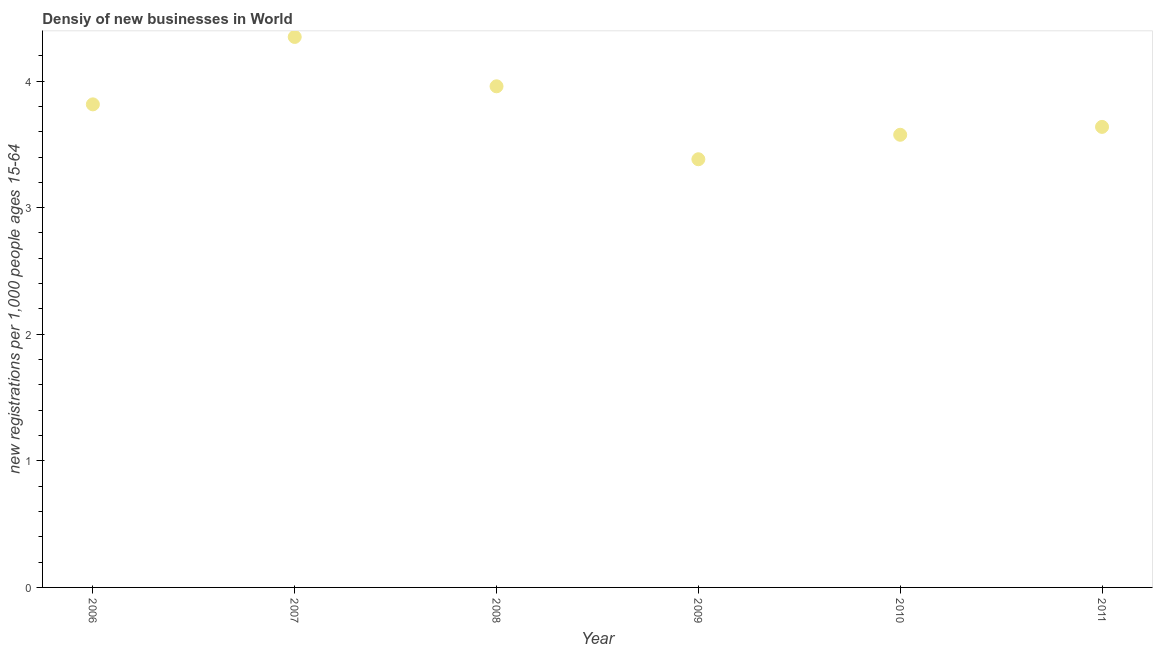What is the density of new business in 2008?
Provide a succinct answer. 3.96. Across all years, what is the maximum density of new business?
Offer a very short reply. 4.35. Across all years, what is the minimum density of new business?
Your answer should be very brief. 3.38. In which year was the density of new business minimum?
Provide a short and direct response. 2009. What is the sum of the density of new business?
Your answer should be compact. 22.72. What is the difference between the density of new business in 2007 and 2008?
Provide a succinct answer. 0.39. What is the average density of new business per year?
Offer a very short reply. 3.79. What is the median density of new business?
Offer a very short reply. 3.73. In how many years, is the density of new business greater than 4 ?
Your answer should be very brief. 1. What is the ratio of the density of new business in 2006 to that in 2010?
Offer a terse response. 1.07. Is the density of new business in 2006 less than that in 2010?
Ensure brevity in your answer.  No. What is the difference between the highest and the second highest density of new business?
Keep it short and to the point. 0.39. Is the sum of the density of new business in 2008 and 2010 greater than the maximum density of new business across all years?
Your answer should be very brief. Yes. What is the difference between the highest and the lowest density of new business?
Your answer should be very brief. 0.97. Does the density of new business monotonically increase over the years?
Your response must be concise. No. How many years are there in the graph?
Give a very brief answer. 6. What is the difference between two consecutive major ticks on the Y-axis?
Give a very brief answer. 1. Does the graph contain grids?
Make the answer very short. No. What is the title of the graph?
Ensure brevity in your answer.  Densiy of new businesses in World. What is the label or title of the Y-axis?
Your answer should be very brief. New registrations per 1,0 people ages 15-64. What is the new registrations per 1,000 people ages 15-64 in 2006?
Your response must be concise. 3.82. What is the new registrations per 1,000 people ages 15-64 in 2007?
Your answer should be very brief. 4.35. What is the new registrations per 1,000 people ages 15-64 in 2008?
Provide a succinct answer. 3.96. What is the new registrations per 1,000 people ages 15-64 in 2009?
Your response must be concise. 3.38. What is the new registrations per 1,000 people ages 15-64 in 2010?
Your answer should be very brief. 3.58. What is the new registrations per 1,000 people ages 15-64 in 2011?
Offer a terse response. 3.64. What is the difference between the new registrations per 1,000 people ages 15-64 in 2006 and 2007?
Give a very brief answer. -0.53. What is the difference between the new registrations per 1,000 people ages 15-64 in 2006 and 2008?
Keep it short and to the point. -0.14. What is the difference between the new registrations per 1,000 people ages 15-64 in 2006 and 2009?
Offer a terse response. 0.43. What is the difference between the new registrations per 1,000 people ages 15-64 in 2006 and 2010?
Offer a very short reply. 0.24. What is the difference between the new registrations per 1,000 people ages 15-64 in 2006 and 2011?
Offer a very short reply. 0.18. What is the difference between the new registrations per 1,000 people ages 15-64 in 2007 and 2008?
Keep it short and to the point. 0.39. What is the difference between the new registrations per 1,000 people ages 15-64 in 2007 and 2009?
Offer a very short reply. 0.97. What is the difference between the new registrations per 1,000 people ages 15-64 in 2007 and 2010?
Ensure brevity in your answer.  0.77. What is the difference between the new registrations per 1,000 people ages 15-64 in 2007 and 2011?
Your response must be concise. 0.71. What is the difference between the new registrations per 1,000 people ages 15-64 in 2008 and 2009?
Offer a terse response. 0.58. What is the difference between the new registrations per 1,000 people ages 15-64 in 2008 and 2010?
Give a very brief answer. 0.38. What is the difference between the new registrations per 1,000 people ages 15-64 in 2008 and 2011?
Offer a very short reply. 0.32. What is the difference between the new registrations per 1,000 people ages 15-64 in 2009 and 2010?
Give a very brief answer. -0.19. What is the difference between the new registrations per 1,000 people ages 15-64 in 2009 and 2011?
Provide a short and direct response. -0.26. What is the difference between the new registrations per 1,000 people ages 15-64 in 2010 and 2011?
Keep it short and to the point. -0.06. What is the ratio of the new registrations per 1,000 people ages 15-64 in 2006 to that in 2007?
Your response must be concise. 0.88. What is the ratio of the new registrations per 1,000 people ages 15-64 in 2006 to that in 2009?
Make the answer very short. 1.13. What is the ratio of the new registrations per 1,000 people ages 15-64 in 2006 to that in 2010?
Provide a short and direct response. 1.07. What is the ratio of the new registrations per 1,000 people ages 15-64 in 2006 to that in 2011?
Offer a terse response. 1.05. What is the ratio of the new registrations per 1,000 people ages 15-64 in 2007 to that in 2008?
Your answer should be very brief. 1.1. What is the ratio of the new registrations per 1,000 people ages 15-64 in 2007 to that in 2009?
Your answer should be very brief. 1.29. What is the ratio of the new registrations per 1,000 people ages 15-64 in 2007 to that in 2010?
Offer a terse response. 1.22. What is the ratio of the new registrations per 1,000 people ages 15-64 in 2007 to that in 2011?
Give a very brief answer. 1.2. What is the ratio of the new registrations per 1,000 people ages 15-64 in 2008 to that in 2009?
Your answer should be compact. 1.17. What is the ratio of the new registrations per 1,000 people ages 15-64 in 2008 to that in 2010?
Your answer should be very brief. 1.11. What is the ratio of the new registrations per 1,000 people ages 15-64 in 2008 to that in 2011?
Give a very brief answer. 1.09. What is the ratio of the new registrations per 1,000 people ages 15-64 in 2009 to that in 2010?
Your answer should be compact. 0.95. What is the ratio of the new registrations per 1,000 people ages 15-64 in 2009 to that in 2011?
Your answer should be very brief. 0.93. 